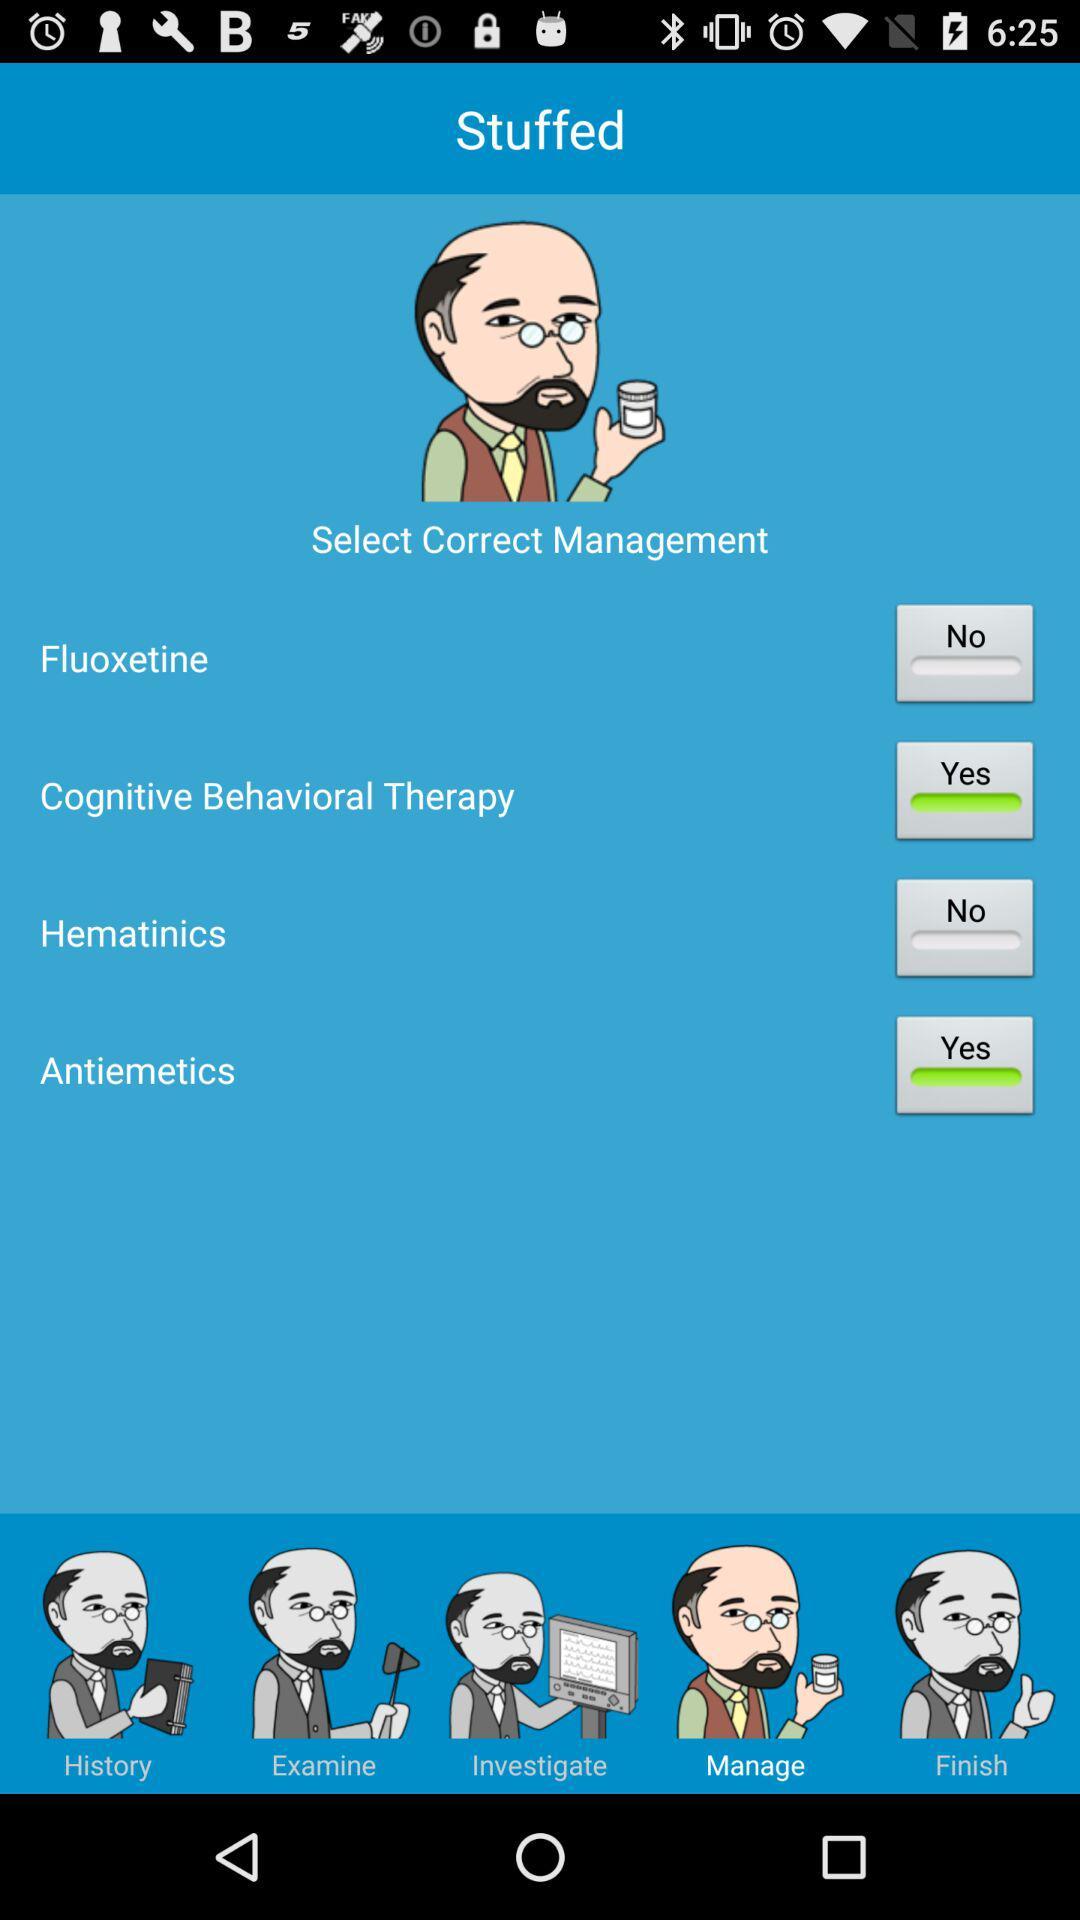Which types of management are not selected? The not selected management options are "Fluoxetine" and "Hematinics". 